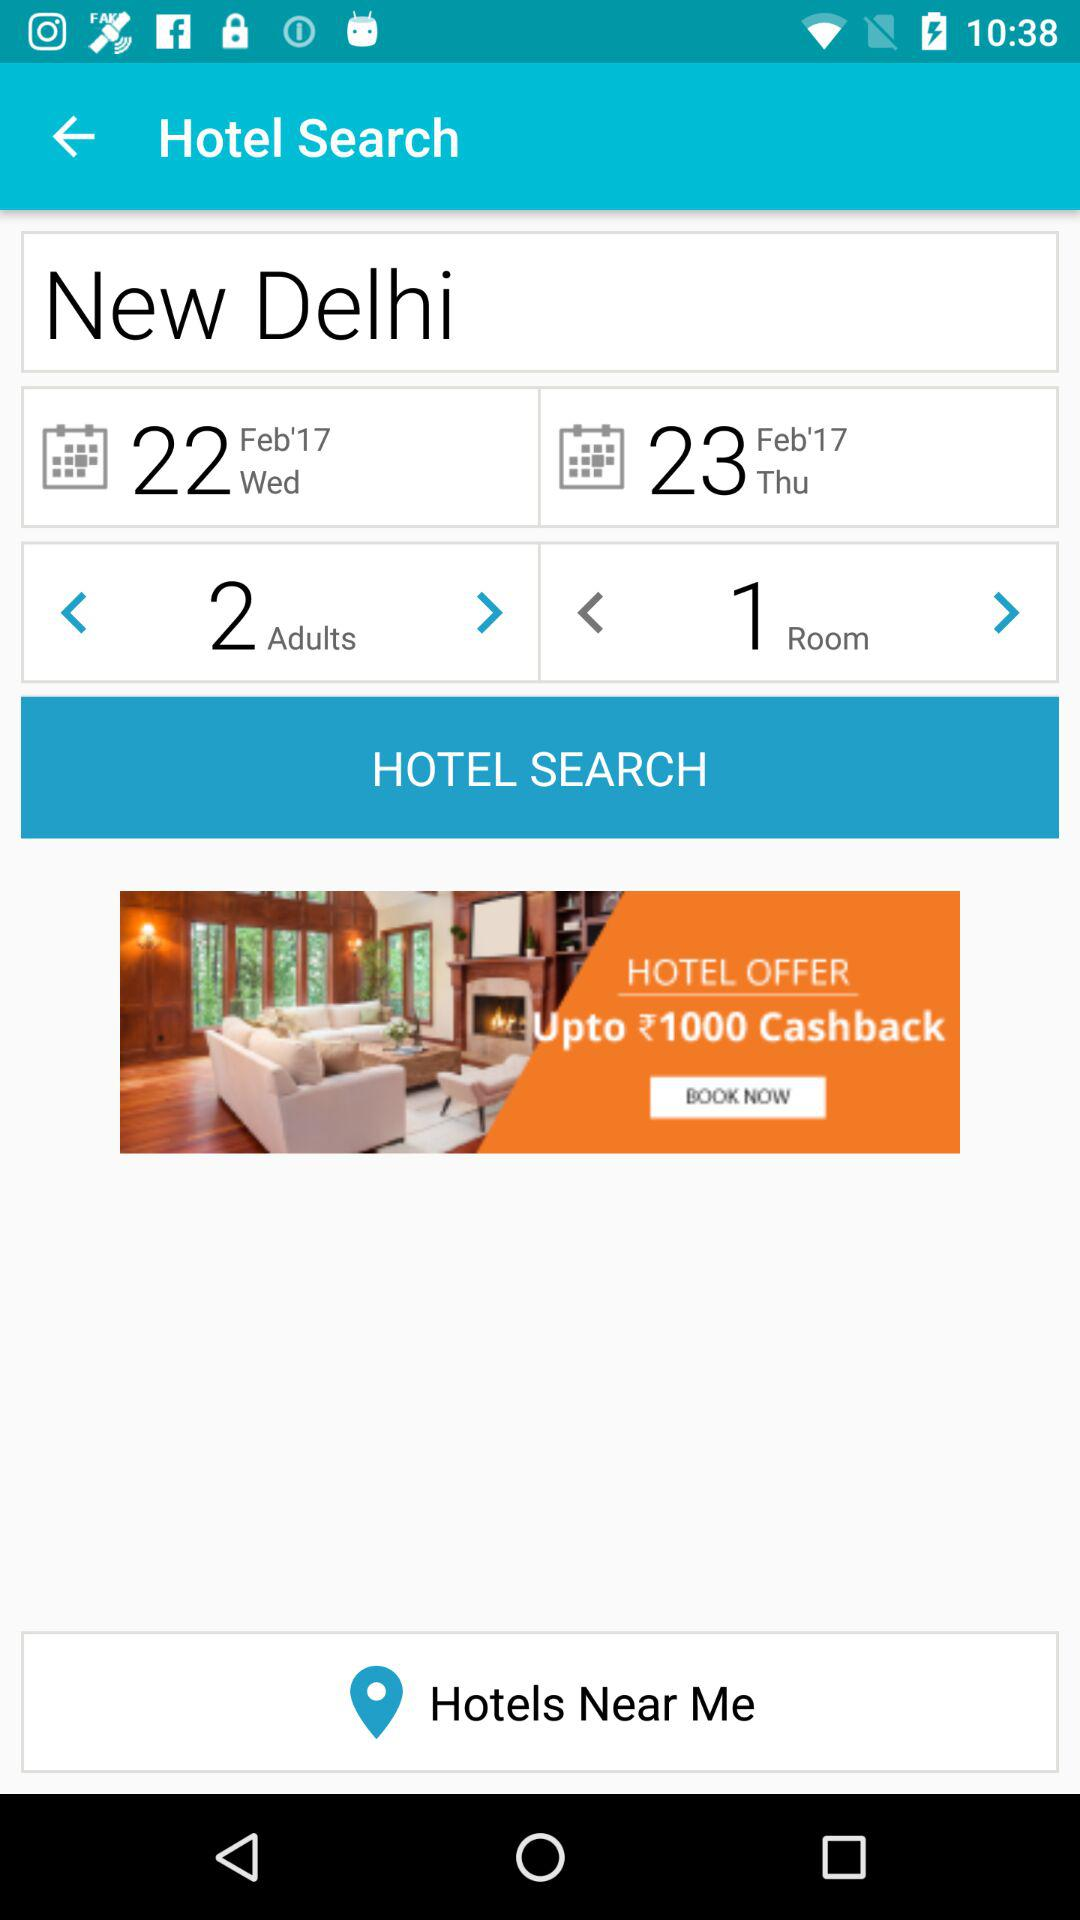How many adults are there? There are 2 adults. 